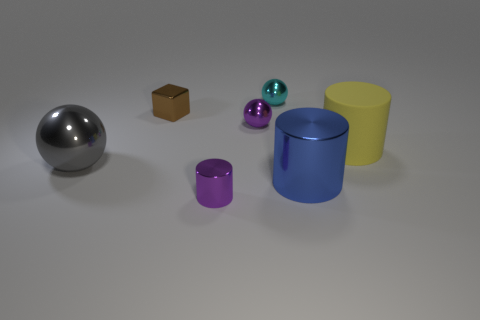What number of tiny objects are the same color as the tiny cylinder? There is only one tiny object that has the same purple color as the tiny cylinder, which is the small sphere next to it. 